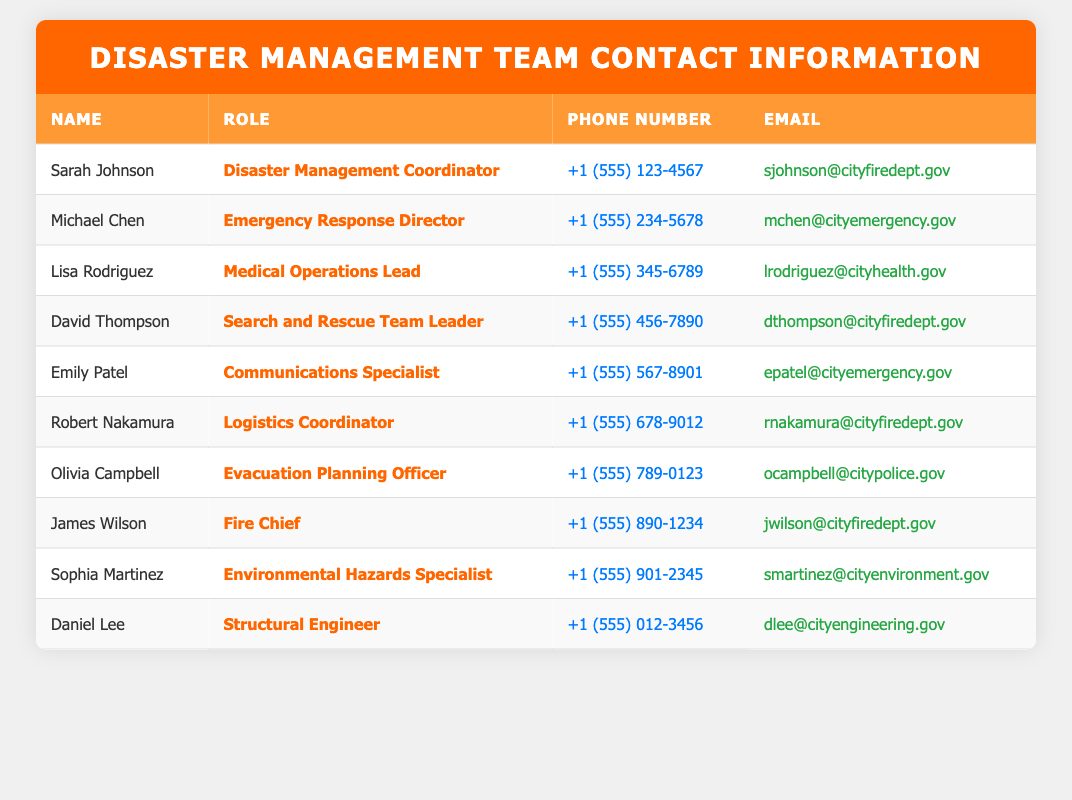What is the phone number of the Disaster Management Coordinator? The Disaster Management Coordinator is Sarah Johnson. I look for her details in the table, specifically the "Phone Number" column corresponding to her name. Her phone number is listed as "+1 (555) 123-4567".
Answer: +1 (555) 123-4567 Who is responsible for Medical Operations? Lisa Rodriguez is identified as the "Medical Operations Lead" in the Role column of the table. I can directly refer to the "Name" column to find her name.
Answer: Lisa Rodriguez How many team members have "Logistics" in their role title? The table lists the roles, and I scan for the term "Logistics". There is one entry: Robert Nakamura as the "Logistics Coordinator". Hence, there is one team member with "Logistics" in their role.
Answer: 1 Is Michael Chen's email address from the fire department? Michael Chen's email address is "mchen@cityemergency.gov". To determine if it is from the fire department, I check if the domain "cityfiredept.gov" is mentioned; it is not. Therefore, his email is not from the fire department.
Answer: No List the names of individuals who handle evacuation planning and environmental hazards. I check the roles in the table for "Evacuation Planning Officer" and "Environmental Hazards Specialist". Olivia Campbell is the Evacuation Planning Officer, and Sophia Martinez is the Environmental Hazards Specialist. I combine these two names into a list of individuals in these roles.
Answer: Olivia Campbell, Sophia Martinez What is the average phone number length among the listed team members? Each phone number is in the format that includes a country code and numbers. I count the number of digits in all phone numbers but ignore the formatting characters like + and parentheses. Each phone number has 14 characters. Since there are 10 team members, the average is still 14.
Answer: 14 Does David Thompson have a higher role than James Wilson? David Thompson's role is "Search and Rescue Team Leader", and James Wilson is the "Fire Chief". I compare these titles based on typical organizational structure; the Fire Chief is usually higher than a Team Leader. Hence, David does not have a higher role.
Answer: No Which two individuals handle communication and logistics? I look for "Communications Specialist" and "Logistics Coordinator" in the table. Emily Patel is listed as a Communications Specialist, while Robert Nakamura is listed as a Logistics Coordinator. I combine their names for clarity.
Answer: Emily Patel, Robert Nakamura 